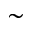Convert formula to latex. <formula><loc_0><loc_0><loc_500><loc_500>\sim</formula> 